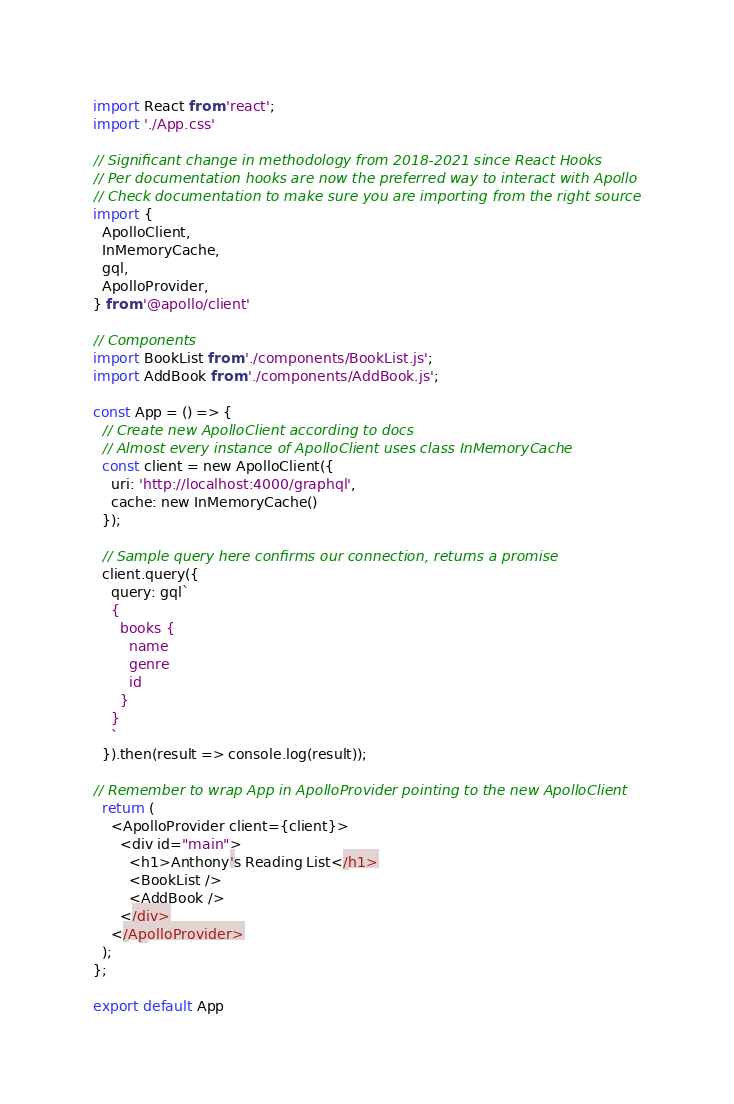Convert code to text. <code><loc_0><loc_0><loc_500><loc_500><_JavaScript_>import React from 'react';
import './App.css'

// Significant change in methodology from 2018-2021 since React Hooks
// Per documentation hooks are now the preferred way to interact with Apollo
// Check documentation to make sure you are importing from the right source
import { 
  ApolloClient, 
  InMemoryCache, 
  gql,
  ApolloProvider, 
} from '@apollo/client'

// Components
import BookList from './components/BookList.js';
import AddBook from './components/AddBook.js';

const App = () => {
  // Create new ApolloClient according to docs
  // Almost every instance of ApolloClient uses class InMemoryCache
  const client = new ApolloClient({
    uri: 'http://localhost:4000/graphql',
    cache: new InMemoryCache()
  });

  // Sample query here confirms our connection, returns a promise
  client.query({
    query: gql`
    {
      books {
        name
        genre
        id
      }
    }
    `
  }).then(result => console.log(result));

// Remember to wrap App in ApolloProvider pointing to the new ApolloClient
  return (
    <ApolloProvider client={client}>
      <div id="main">
        <h1>Anthony's Reading List</h1>
        <BookList />
        <AddBook />
      </div>
    </ApolloProvider>
  );
};

export default App</code> 